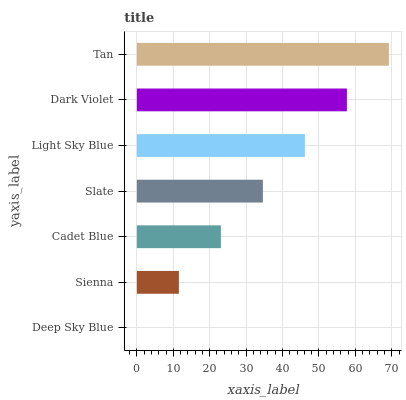Is Deep Sky Blue the minimum?
Answer yes or no. Yes. Is Tan the maximum?
Answer yes or no. Yes. Is Sienna the minimum?
Answer yes or no. No. Is Sienna the maximum?
Answer yes or no. No. Is Sienna greater than Deep Sky Blue?
Answer yes or no. Yes. Is Deep Sky Blue less than Sienna?
Answer yes or no. Yes. Is Deep Sky Blue greater than Sienna?
Answer yes or no. No. Is Sienna less than Deep Sky Blue?
Answer yes or no. No. Is Slate the high median?
Answer yes or no. Yes. Is Slate the low median?
Answer yes or no. Yes. Is Cadet Blue the high median?
Answer yes or no. No. Is Tan the low median?
Answer yes or no. No. 